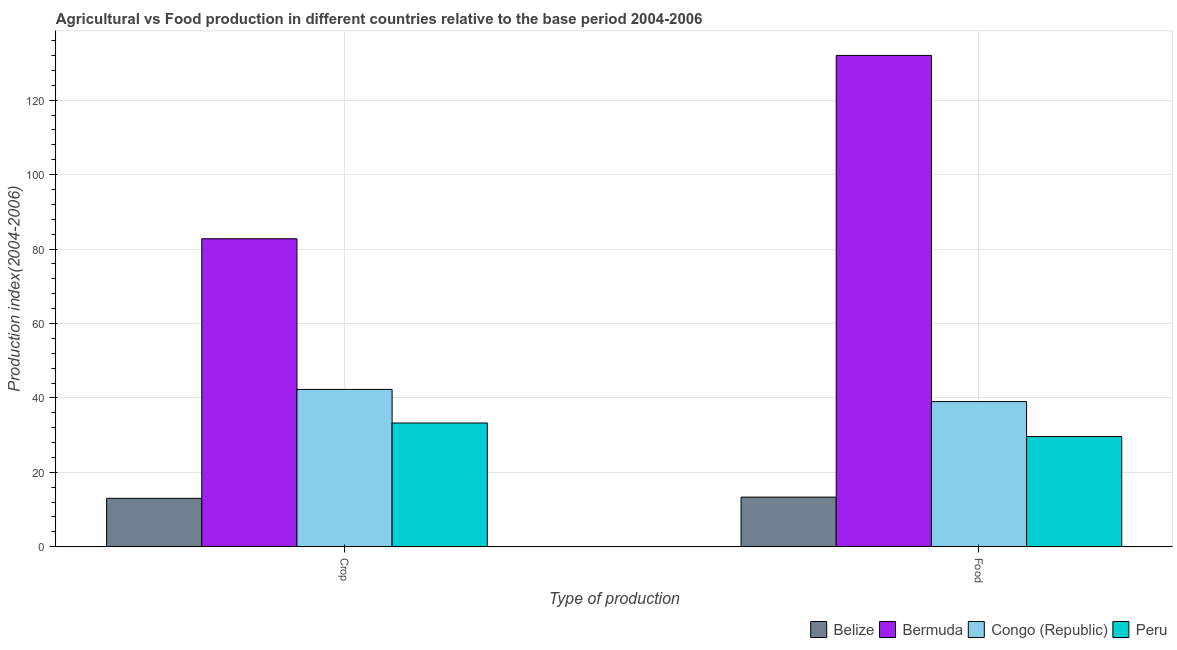Are the number of bars per tick equal to the number of legend labels?
Provide a short and direct response. Yes. How many bars are there on the 2nd tick from the right?
Keep it short and to the point. 4. What is the label of the 2nd group of bars from the left?
Your response must be concise. Food. What is the food production index in Bermuda?
Offer a very short reply. 132.04. Across all countries, what is the maximum food production index?
Your response must be concise. 132.04. Across all countries, what is the minimum crop production index?
Your answer should be very brief. 13.01. In which country was the food production index maximum?
Offer a terse response. Bermuda. In which country was the food production index minimum?
Your answer should be compact. Belize. What is the total crop production index in the graph?
Offer a very short reply. 171.32. What is the difference between the food production index in Congo (Republic) and that in Bermuda?
Keep it short and to the point. -93.03. What is the difference between the food production index in Belize and the crop production index in Peru?
Keep it short and to the point. -19.92. What is the average crop production index per country?
Keep it short and to the point. 42.83. What is the difference between the crop production index and food production index in Congo (Republic)?
Your answer should be very brief. 3.27. In how many countries, is the food production index greater than 116 ?
Your response must be concise. 1. What is the ratio of the crop production index in Congo (Republic) to that in Bermuda?
Keep it short and to the point. 0.51. What does the 1st bar from the left in Food represents?
Offer a terse response. Belize. What does the 4th bar from the right in Food represents?
Offer a very short reply. Belize. How many bars are there?
Provide a succinct answer. 8. How many countries are there in the graph?
Offer a terse response. 4. What is the difference between two consecutive major ticks on the Y-axis?
Offer a very short reply. 20. Are the values on the major ticks of Y-axis written in scientific E-notation?
Your answer should be compact. No. How many legend labels are there?
Your answer should be very brief. 4. How are the legend labels stacked?
Provide a short and direct response. Horizontal. What is the title of the graph?
Ensure brevity in your answer.  Agricultural vs Food production in different countries relative to the base period 2004-2006. Does "Mauritania" appear as one of the legend labels in the graph?
Provide a short and direct response. No. What is the label or title of the X-axis?
Ensure brevity in your answer.  Type of production. What is the label or title of the Y-axis?
Offer a very short reply. Production index(2004-2006). What is the Production index(2004-2006) of Belize in Crop?
Offer a very short reply. 13.01. What is the Production index(2004-2006) in Bermuda in Crop?
Ensure brevity in your answer.  82.77. What is the Production index(2004-2006) in Congo (Republic) in Crop?
Make the answer very short. 42.28. What is the Production index(2004-2006) of Peru in Crop?
Your response must be concise. 33.26. What is the Production index(2004-2006) in Belize in Food?
Offer a very short reply. 13.34. What is the Production index(2004-2006) in Bermuda in Food?
Provide a succinct answer. 132.04. What is the Production index(2004-2006) of Congo (Republic) in Food?
Your answer should be very brief. 39.01. What is the Production index(2004-2006) of Peru in Food?
Offer a terse response. 29.61. Across all Type of production, what is the maximum Production index(2004-2006) of Belize?
Offer a terse response. 13.34. Across all Type of production, what is the maximum Production index(2004-2006) in Bermuda?
Offer a terse response. 132.04. Across all Type of production, what is the maximum Production index(2004-2006) of Congo (Republic)?
Ensure brevity in your answer.  42.28. Across all Type of production, what is the maximum Production index(2004-2006) in Peru?
Your answer should be very brief. 33.26. Across all Type of production, what is the minimum Production index(2004-2006) in Belize?
Keep it short and to the point. 13.01. Across all Type of production, what is the minimum Production index(2004-2006) of Bermuda?
Keep it short and to the point. 82.77. Across all Type of production, what is the minimum Production index(2004-2006) of Congo (Republic)?
Your answer should be compact. 39.01. Across all Type of production, what is the minimum Production index(2004-2006) of Peru?
Give a very brief answer. 29.61. What is the total Production index(2004-2006) in Belize in the graph?
Offer a terse response. 26.35. What is the total Production index(2004-2006) of Bermuda in the graph?
Offer a very short reply. 214.81. What is the total Production index(2004-2006) of Congo (Republic) in the graph?
Offer a very short reply. 81.29. What is the total Production index(2004-2006) of Peru in the graph?
Provide a short and direct response. 62.87. What is the difference between the Production index(2004-2006) in Belize in Crop and that in Food?
Offer a very short reply. -0.33. What is the difference between the Production index(2004-2006) in Bermuda in Crop and that in Food?
Make the answer very short. -49.27. What is the difference between the Production index(2004-2006) in Congo (Republic) in Crop and that in Food?
Provide a short and direct response. 3.27. What is the difference between the Production index(2004-2006) of Peru in Crop and that in Food?
Your response must be concise. 3.65. What is the difference between the Production index(2004-2006) in Belize in Crop and the Production index(2004-2006) in Bermuda in Food?
Keep it short and to the point. -119.03. What is the difference between the Production index(2004-2006) of Belize in Crop and the Production index(2004-2006) of Peru in Food?
Keep it short and to the point. -16.6. What is the difference between the Production index(2004-2006) in Bermuda in Crop and the Production index(2004-2006) in Congo (Republic) in Food?
Ensure brevity in your answer.  43.76. What is the difference between the Production index(2004-2006) in Bermuda in Crop and the Production index(2004-2006) in Peru in Food?
Give a very brief answer. 53.16. What is the difference between the Production index(2004-2006) of Congo (Republic) in Crop and the Production index(2004-2006) of Peru in Food?
Your answer should be very brief. 12.67. What is the average Production index(2004-2006) of Belize per Type of production?
Keep it short and to the point. 13.18. What is the average Production index(2004-2006) of Bermuda per Type of production?
Make the answer very short. 107.41. What is the average Production index(2004-2006) of Congo (Republic) per Type of production?
Give a very brief answer. 40.65. What is the average Production index(2004-2006) of Peru per Type of production?
Ensure brevity in your answer.  31.43. What is the difference between the Production index(2004-2006) in Belize and Production index(2004-2006) in Bermuda in Crop?
Your answer should be very brief. -69.76. What is the difference between the Production index(2004-2006) in Belize and Production index(2004-2006) in Congo (Republic) in Crop?
Offer a terse response. -29.27. What is the difference between the Production index(2004-2006) in Belize and Production index(2004-2006) in Peru in Crop?
Your answer should be compact. -20.25. What is the difference between the Production index(2004-2006) of Bermuda and Production index(2004-2006) of Congo (Republic) in Crop?
Your answer should be very brief. 40.49. What is the difference between the Production index(2004-2006) in Bermuda and Production index(2004-2006) in Peru in Crop?
Make the answer very short. 49.51. What is the difference between the Production index(2004-2006) of Congo (Republic) and Production index(2004-2006) of Peru in Crop?
Ensure brevity in your answer.  9.02. What is the difference between the Production index(2004-2006) in Belize and Production index(2004-2006) in Bermuda in Food?
Give a very brief answer. -118.7. What is the difference between the Production index(2004-2006) in Belize and Production index(2004-2006) in Congo (Republic) in Food?
Offer a very short reply. -25.67. What is the difference between the Production index(2004-2006) of Belize and Production index(2004-2006) of Peru in Food?
Provide a succinct answer. -16.27. What is the difference between the Production index(2004-2006) in Bermuda and Production index(2004-2006) in Congo (Republic) in Food?
Keep it short and to the point. 93.03. What is the difference between the Production index(2004-2006) of Bermuda and Production index(2004-2006) of Peru in Food?
Keep it short and to the point. 102.43. What is the difference between the Production index(2004-2006) of Congo (Republic) and Production index(2004-2006) of Peru in Food?
Provide a short and direct response. 9.4. What is the ratio of the Production index(2004-2006) of Belize in Crop to that in Food?
Your response must be concise. 0.98. What is the ratio of the Production index(2004-2006) in Bermuda in Crop to that in Food?
Provide a short and direct response. 0.63. What is the ratio of the Production index(2004-2006) of Congo (Republic) in Crop to that in Food?
Provide a short and direct response. 1.08. What is the ratio of the Production index(2004-2006) in Peru in Crop to that in Food?
Provide a succinct answer. 1.12. What is the difference between the highest and the second highest Production index(2004-2006) in Belize?
Your response must be concise. 0.33. What is the difference between the highest and the second highest Production index(2004-2006) of Bermuda?
Give a very brief answer. 49.27. What is the difference between the highest and the second highest Production index(2004-2006) of Congo (Republic)?
Your response must be concise. 3.27. What is the difference between the highest and the second highest Production index(2004-2006) of Peru?
Ensure brevity in your answer.  3.65. What is the difference between the highest and the lowest Production index(2004-2006) in Belize?
Keep it short and to the point. 0.33. What is the difference between the highest and the lowest Production index(2004-2006) in Bermuda?
Your answer should be compact. 49.27. What is the difference between the highest and the lowest Production index(2004-2006) of Congo (Republic)?
Your answer should be compact. 3.27. What is the difference between the highest and the lowest Production index(2004-2006) of Peru?
Your answer should be very brief. 3.65. 